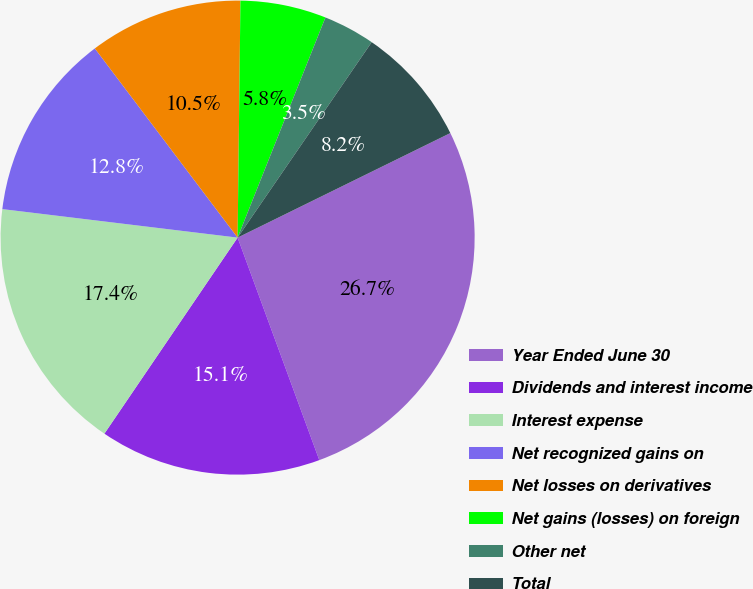Convert chart. <chart><loc_0><loc_0><loc_500><loc_500><pie_chart><fcel>Year Ended June 30<fcel>Dividends and interest income<fcel>Interest expense<fcel>Net recognized gains on<fcel>Net losses on derivatives<fcel>Net gains (losses) on foreign<fcel>Other net<fcel>Total<nl><fcel>26.67%<fcel>15.1%<fcel>17.42%<fcel>12.79%<fcel>10.48%<fcel>5.85%<fcel>3.53%<fcel>8.16%<nl></chart> 